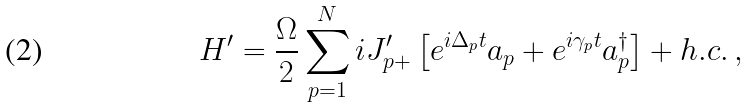<formula> <loc_0><loc_0><loc_500><loc_500>H ^ { \prime } = \frac { \Omega } { 2 } \sum _ { p = 1 } ^ { N } i J _ { p + } ^ { \prime } \left [ e ^ { i \Delta _ { p } t } a _ { p } + e ^ { i \gamma _ { p } t } a _ { p } ^ { \dag } \right ] + h . c . \, ,</formula> 